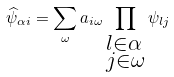Convert formula to latex. <formula><loc_0><loc_0><loc_500><loc_500>\widehat { \psi } _ { \alpha i } = \sum _ { \omega } a _ { i \omega } \prod _ { \begin{subarray} { c } l \in \alpha \\ j \in \omega \end{subarray} } \psi _ { l j }</formula> 